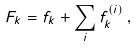<formula> <loc_0><loc_0><loc_500><loc_500>F _ { k } = f _ { k } + \sum _ { i } f ^ { ( i ) } _ { k } \, ,</formula> 